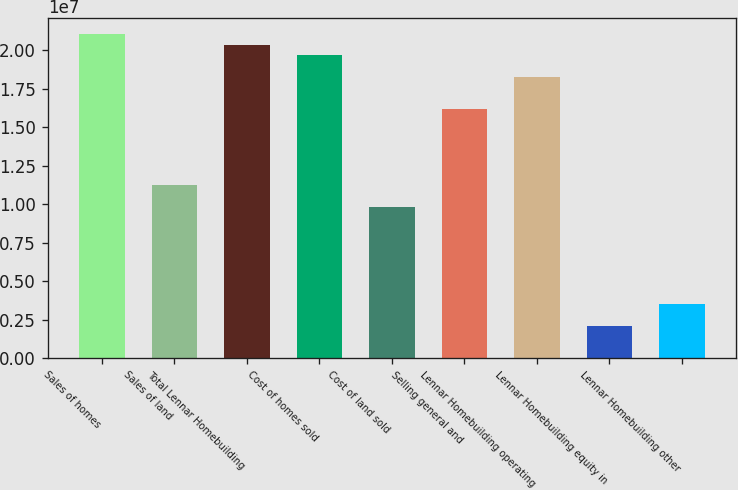Convert chart to OTSL. <chart><loc_0><loc_0><loc_500><loc_500><bar_chart><fcel>Sales of homes<fcel>Sales of land<fcel>Total Lennar Homebuilding<fcel>Cost of homes sold<fcel>Cost of land sold<fcel>Selling general and<fcel>Lennar Homebuilding operating<fcel>Lennar Homebuilding equity in<fcel>Lennar Homebuilding other<nl><fcel>2.10754e+07<fcel>1.12402e+07<fcel>2.03729e+07<fcel>1.96703e+07<fcel>9.83518e+06<fcel>1.61578e+07<fcel>1.82653e+07<fcel>2.10755e+06<fcel>3.51257e+06<nl></chart> 